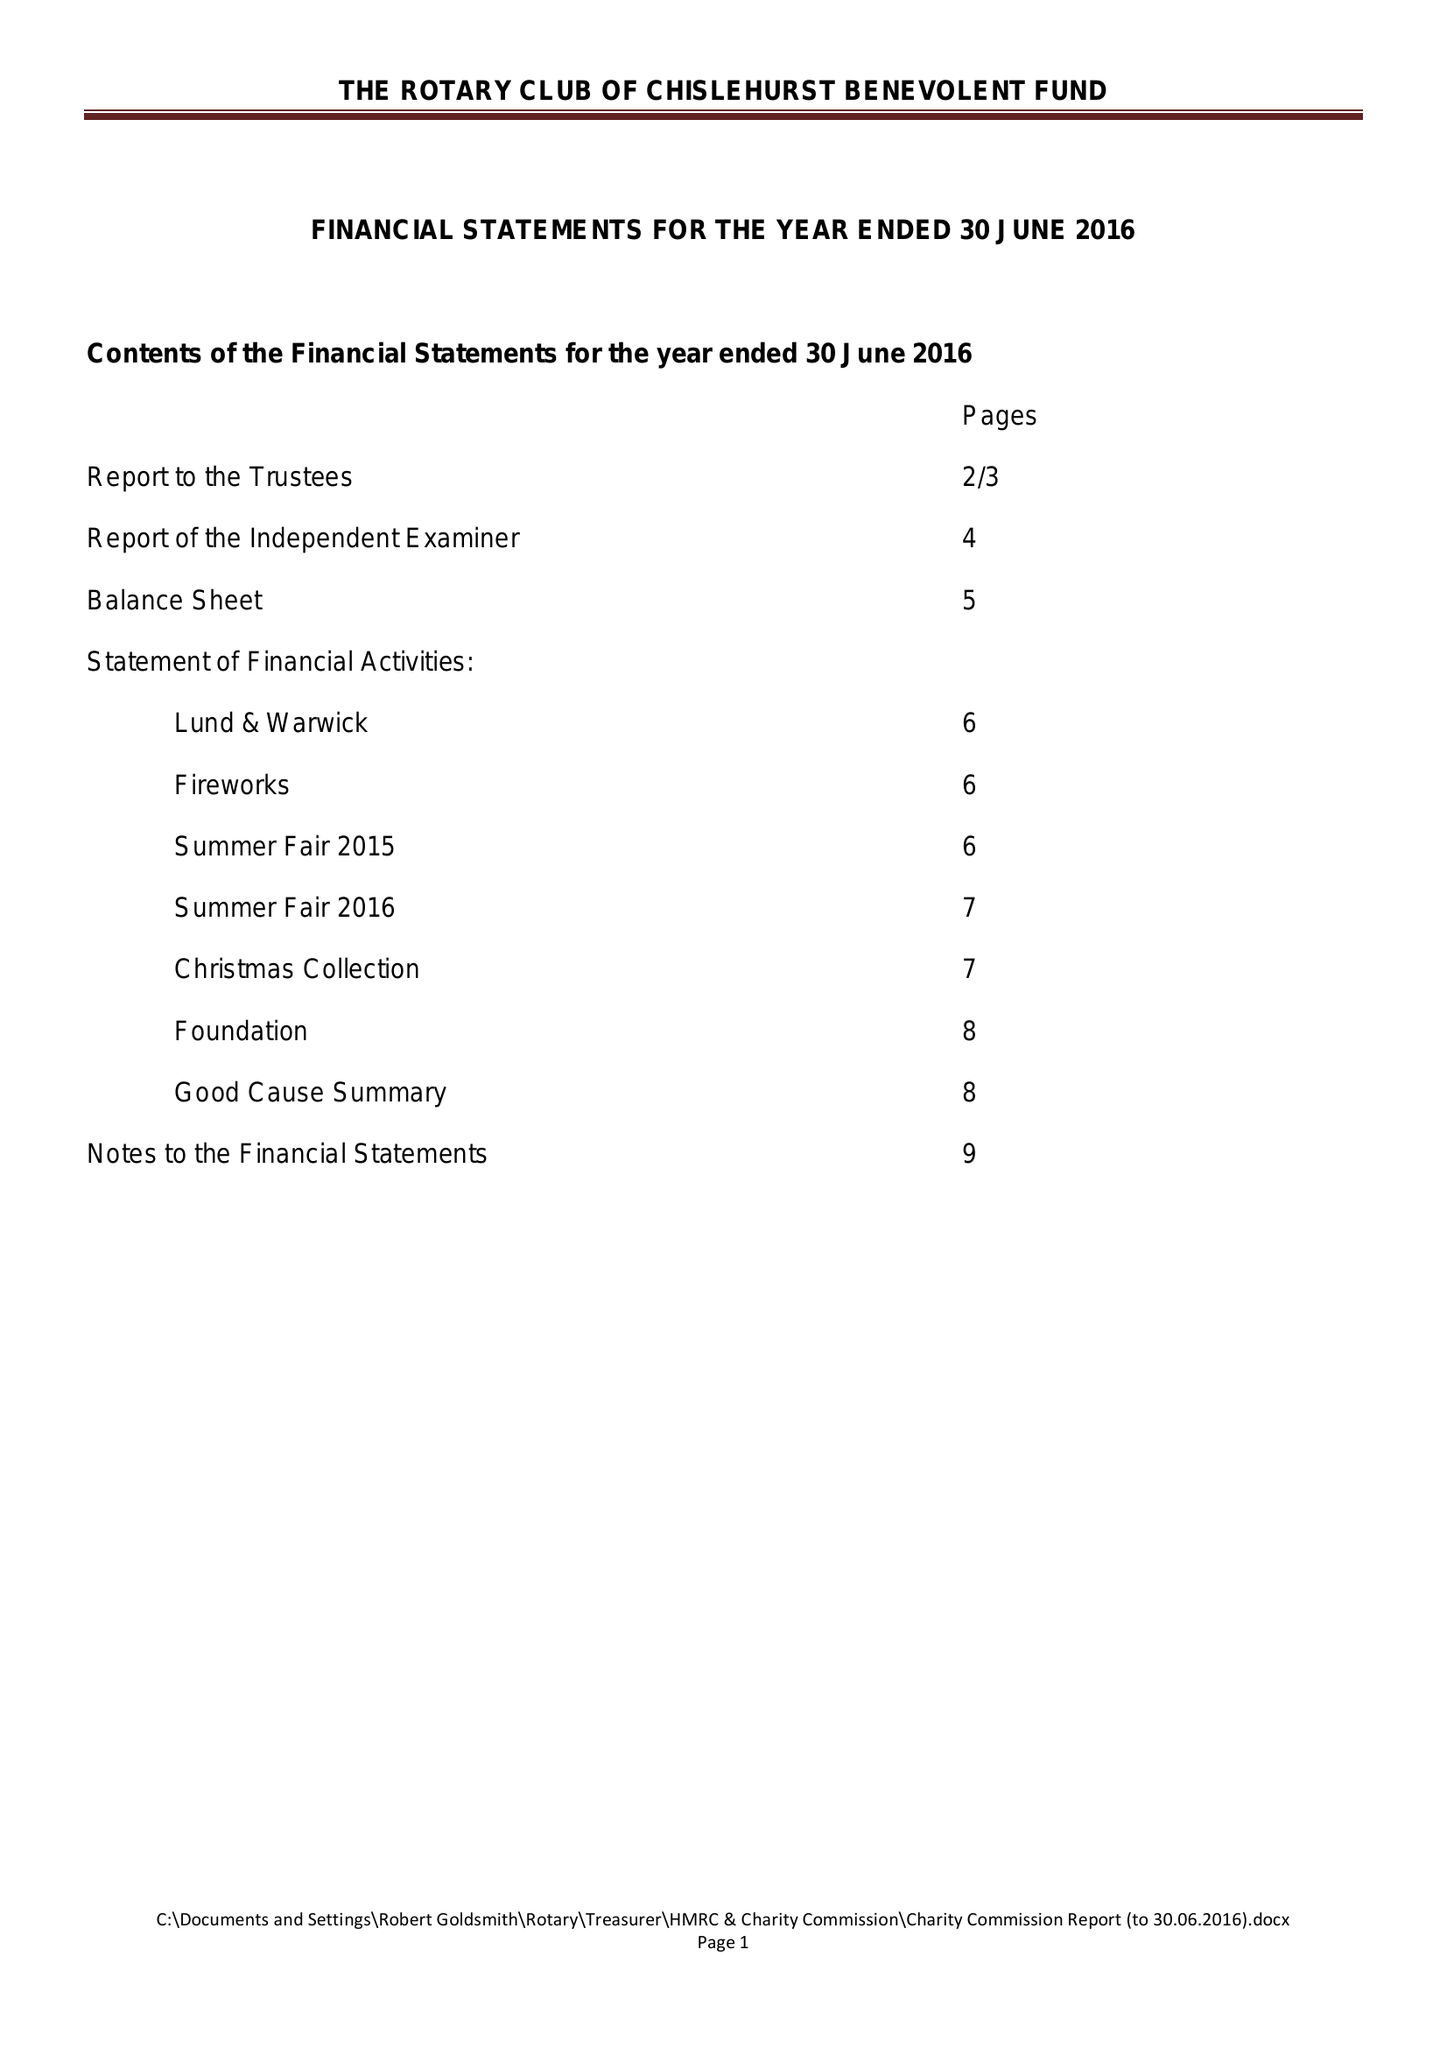What is the value for the address__street_line?
Answer the question using a single word or phrase. CHELSFIELD LANE 